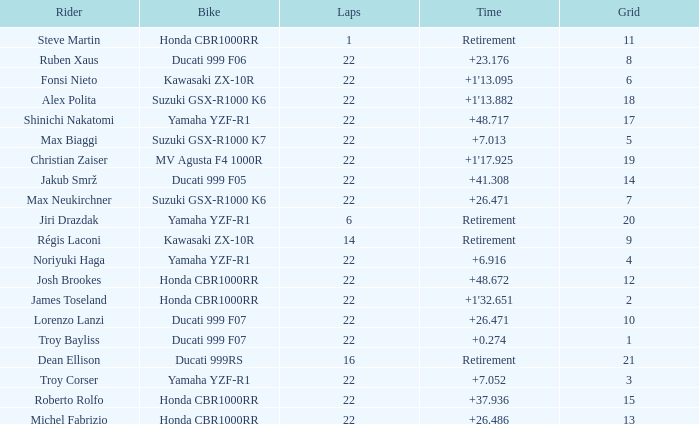Which bike did Jiri Drazdak ride when he had a grid number larger than 14 and less than 22 laps? Yamaha YZF-R1. Would you mind parsing the complete table? {'header': ['Rider', 'Bike', 'Laps', 'Time', 'Grid'], 'rows': [['Steve Martin', 'Honda CBR1000RR', '1', 'Retirement', '11'], ['Ruben Xaus', 'Ducati 999 F06', '22', '+23.176', '8'], ['Fonsi Nieto', 'Kawasaki ZX-10R', '22', "+1'13.095", '6'], ['Alex Polita', 'Suzuki GSX-R1000 K6', '22', "+1'13.882", '18'], ['Shinichi Nakatomi', 'Yamaha YZF-R1', '22', '+48.717', '17'], ['Max Biaggi', 'Suzuki GSX-R1000 K7', '22', '+7.013', '5'], ['Christian Zaiser', 'MV Agusta F4 1000R', '22', "+1'17.925", '19'], ['Jakub Smrž', 'Ducati 999 F05', '22', '+41.308', '14'], ['Max Neukirchner', 'Suzuki GSX-R1000 K6', '22', '+26.471', '7'], ['Jiri Drazdak', 'Yamaha YZF-R1', '6', 'Retirement', '20'], ['Régis Laconi', 'Kawasaki ZX-10R', '14', 'Retirement', '9'], ['Noriyuki Haga', 'Yamaha YZF-R1', '22', '+6.916', '4'], ['Josh Brookes', 'Honda CBR1000RR', '22', '+48.672', '12'], ['James Toseland', 'Honda CBR1000RR', '22', "+1'32.651", '2'], ['Lorenzo Lanzi', 'Ducati 999 F07', '22', '+26.471', '10'], ['Troy Bayliss', 'Ducati 999 F07', '22', '+0.274', '1'], ['Dean Ellison', 'Ducati 999RS', '16', 'Retirement', '21'], ['Troy Corser', 'Yamaha YZF-R1', '22', '+7.052', '3'], ['Roberto Rolfo', 'Honda CBR1000RR', '22', '+37.936', '15'], ['Michel Fabrizio', 'Honda CBR1000RR', '22', '+26.486', '13']]} 